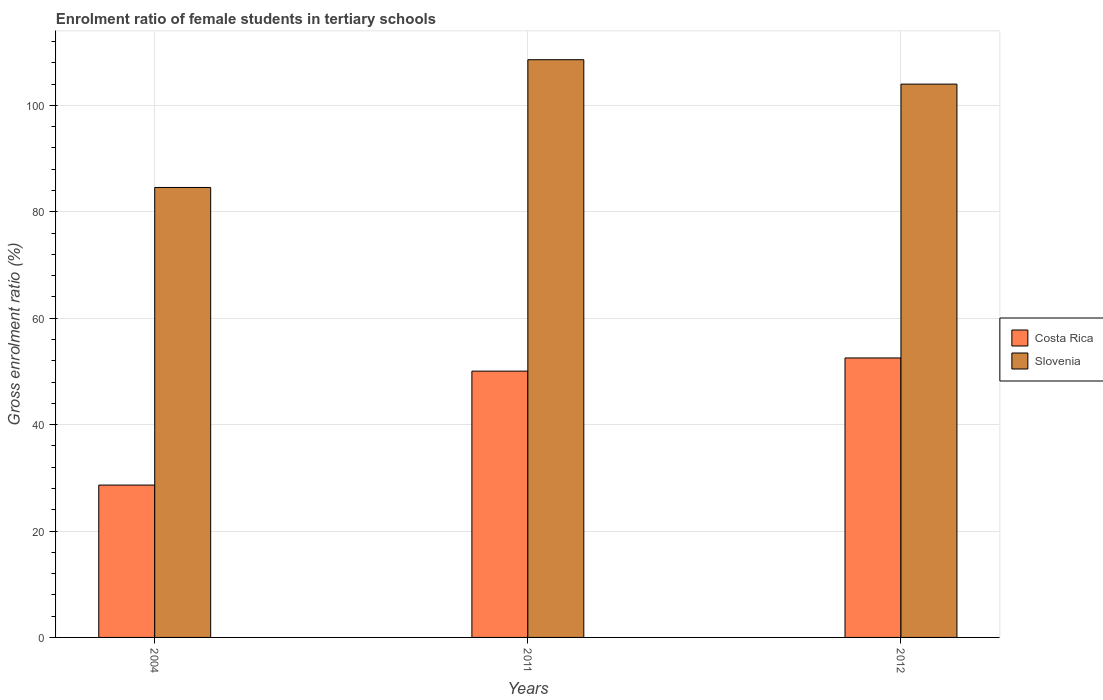How many different coloured bars are there?
Your answer should be compact. 2. How many groups of bars are there?
Provide a succinct answer. 3. Are the number of bars on each tick of the X-axis equal?
Ensure brevity in your answer.  Yes. How many bars are there on the 2nd tick from the left?
Offer a terse response. 2. How many bars are there on the 1st tick from the right?
Your answer should be compact. 2. What is the enrolment ratio of female students in tertiary schools in Slovenia in 2011?
Provide a succinct answer. 108.59. Across all years, what is the maximum enrolment ratio of female students in tertiary schools in Slovenia?
Your answer should be very brief. 108.59. Across all years, what is the minimum enrolment ratio of female students in tertiary schools in Costa Rica?
Keep it short and to the point. 28.64. In which year was the enrolment ratio of female students in tertiary schools in Slovenia minimum?
Your answer should be very brief. 2004. What is the total enrolment ratio of female students in tertiary schools in Costa Rica in the graph?
Your answer should be compact. 131.23. What is the difference between the enrolment ratio of female students in tertiary schools in Slovenia in 2004 and that in 2011?
Your answer should be compact. -24.01. What is the difference between the enrolment ratio of female students in tertiary schools in Costa Rica in 2011 and the enrolment ratio of female students in tertiary schools in Slovenia in 2004?
Provide a short and direct response. -34.52. What is the average enrolment ratio of female students in tertiary schools in Slovenia per year?
Provide a short and direct response. 99.06. In the year 2004, what is the difference between the enrolment ratio of female students in tertiary schools in Costa Rica and enrolment ratio of female students in tertiary schools in Slovenia?
Provide a succinct answer. -55.94. What is the ratio of the enrolment ratio of female students in tertiary schools in Slovenia in 2004 to that in 2011?
Your response must be concise. 0.78. Is the enrolment ratio of female students in tertiary schools in Slovenia in 2004 less than that in 2011?
Ensure brevity in your answer.  Yes. What is the difference between the highest and the second highest enrolment ratio of female students in tertiary schools in Costa Rica?
Provide a short and direct response. 2.48. What is the difference between the highest and the lowest enrolment ratio of female students in tertiary schools in Costa Rica?
Provide a succinct answer. 23.89. In how many years, is the enrolment ratio of female students in tertiary schools in Slovenia greater than the average enrolment ratio of female students in tertiary schools in Slovenia taken over all years?
Make the answer very short. 2. Is the sum of the enrolment ratio of female students in tertiary schools in Slovenia in 2011 and 2012 greater than the maximum enrolment ratio of female students in tertiary schools in Costa Rica across all years?
Offer a terse response. Yes. What does the 1st bar from the left in 2011 represents?
Make the answer very short. Costa Rica. What does the 1st bar from the right in 2004 represents?
Keep it short and to the point. Slovenia. How many bars are there?
Ensure brevity in your answer.  6. Are all the bars in the graph horizontal?
Offer a very short reply. No. How many years are there in the graph?
Provide a succinct answer. 3. What is the difference between two consecutive major ticks on the Y-axis?
Provide a short and direct response. 20. Does the graph contain grids?
Give a very brief answer. Yes. How many legend labels are there?
Provide a succinct answer. 2. How are the legend labels stacked?
Offer a very short reply. Vertical. What is the title of the graph?
Offer a terse response. Enrolment ratio of female students in tertiary schools. Does "Turkmenistan" appear as one of the legend labels in the graph?
Provide a short and direct response. No. What is the label or title of the Y-axis?
Offer a terse response. Gross enrolment ratio (%). What is the Gross enrolment ratio (%) in Costa Rica in 2004?
Provide a succinct answer. 28.64. What is the Gross enrolment ratio (%) in Slovenia in 2004?
Your answer should be very brief. 84.58. What is the Gross enrolment ratio (%) in Costa Rica in 2011?
Your answer should be very brief. 50.05. What is the Gross enrolment ratio (%) in Slovenia in 2011?
Ensure brevity in your answer.  108.59. What is the Gross enrolment ratio (%) of Costa Rica in 2012?
Your response must be concise. 52.53. What is the Gross enrolment ratio (%) in Slovenia in 2012?
Keep it short and to the point. 104. Across all years, what is the maximum Gross enrolment ratio (%) in Costa Rica?
Keep it short and to the point. 52.53. Across all years, what is the maximum Gross enrolment ratio (%) in Slovenia?
Provide a short and direct response. 108.59. Across all years, what is the minimum Gross enrolment ratio (%) in Costa Rica?
Your response must be concise. 28.64. Across all years, what is the minimum Gross enrolment ratio (%) in Slovenia?
Your answer should be very brief. 84.58. What is the total Gross enrolment ratio (%) in Costa Rica in the graph?
Your answer should be very brief. 131.23. What is the total Gross enrolment ratio (%) in Slovenia in the graph?
Give a very brief answer. 297.18. What is the difference between the Gross enrolment ratio (%) in Costa Rica in 2004 and that in 2011?
Your answer should be very brief. -21.42. What is the difference between the Gross enrolment ratio (%) in Slovenia in 2004 and that in 2011?
Your response must be concise. -24.01. What is the difference between the Gross enrolment ratio (%) of Costa Rica in 2004 and that in 2012?
Your response must be concise. -23.89. What is the difference between the Gross enrolment ratio (%) in Slovenia in 2004 and that in 2012?
Offer a very short reply. -19.43. What is the difference between the Gross enrolment ratio (%) of Costa Rica in 2011 and that in 2012?
Your response must be concise. -2.48. What is the difference between the Gross enrolment ratio (%) of Slovenia in 2011 and that in 2012?
Your response must be concise. 4.59. What is the difference between the Gross enrolment ratio (%) of Costa Rica in 2004 and the Gross enrolment ratio (%) of Slovenia in 2011?
Your response must be concise. -79.95. What is the difference between the Gross enrolment ratio (%) in Costa Rica in 2004 and the Gross enrolment ratio (%) in Slovenia in 2012?
Provide a succinct answer. -75.37. What is the difference between the Gross enrolment ratio (%) of Costa Rica in 2011 and the Gross enrolment ratio (%) of Slovenia in 2012?
Keep it short and to the point. -53.95. What is the average Gross enrolment ratio (%) of Costa Rica per year?
Give a very brief answer. 43.74. What is the average Gross enrolment ratio (%) in Slovenia per year?
Keep it short and to the point. 99.06. In the year 2004, what is the difference between the Gross enrolment ratio (%) in Costa Rica and Gross enrolment ratio (%) in Slovenia?
Give a very brief answer. -55.94. In the year 2011, what is the difference between the Gross enrolment ratio (%) of Costa Rica and Gross enrolment ratio (%) of Slovenia?
Keep it short and to the point. -58.54. In the year 2012, what is the difference between the Gross enrolment ratio (%) in Costa Rica and Gross enrolment ratio (%) in Slovenia?
Provide a short and direct response. -51.47. What is the ratio of the Gross enrolment ratio (%) in Costa Rica in 2004 to that in 2011?
Provide a succinct answer. 0.57. What is the ratio of the Gross enrolment ratio (%) in Slovenia in 2004 to that in 2011?
Ensure brevity in your answer.  0.78. What is the ratio of the Gross enrolment ratio (%) of Costa Rica in 2004 to that in 2012?
Provide a short and direct response. 0.55. What is the ratio of the Gross enrolment ratio (%) in Slovenia in 2004 to that in 2012?
Your answer should be compact. 0.81. What is the ratio of the Gross enrolment ratio (%) of Costa Rica in 2011 to that in 2012?
Provide a short and direct response. 0.95. What is the ratio of the Gross enrolment ratio (%) of Slovenia in 2011 to that in 2012?
Offer a terse response. 1.04. What is the difference between the highest and the second highest Gross enrolment ratio (%) of Costa Rica?
Give a very brief answer. 2.48. What is the difference between the highest and the second highest Gross enrolment ratio (%) in Slovenia?
Offer a terse response. 4.59. What is the difference between the highest and the lowest Gross enrolment ratio (%) in Costa Rica?
Make the answer very short. 23.89. What is the difference between the highest and the lowest Gross enrolment ratio (%) in Slovenia?
Give a very brief answer. 24.01. 